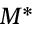Convert formula to latex. <formula><loc_0><loc_0><loc_500><loc_500>M ^ { \ast }</formula> 